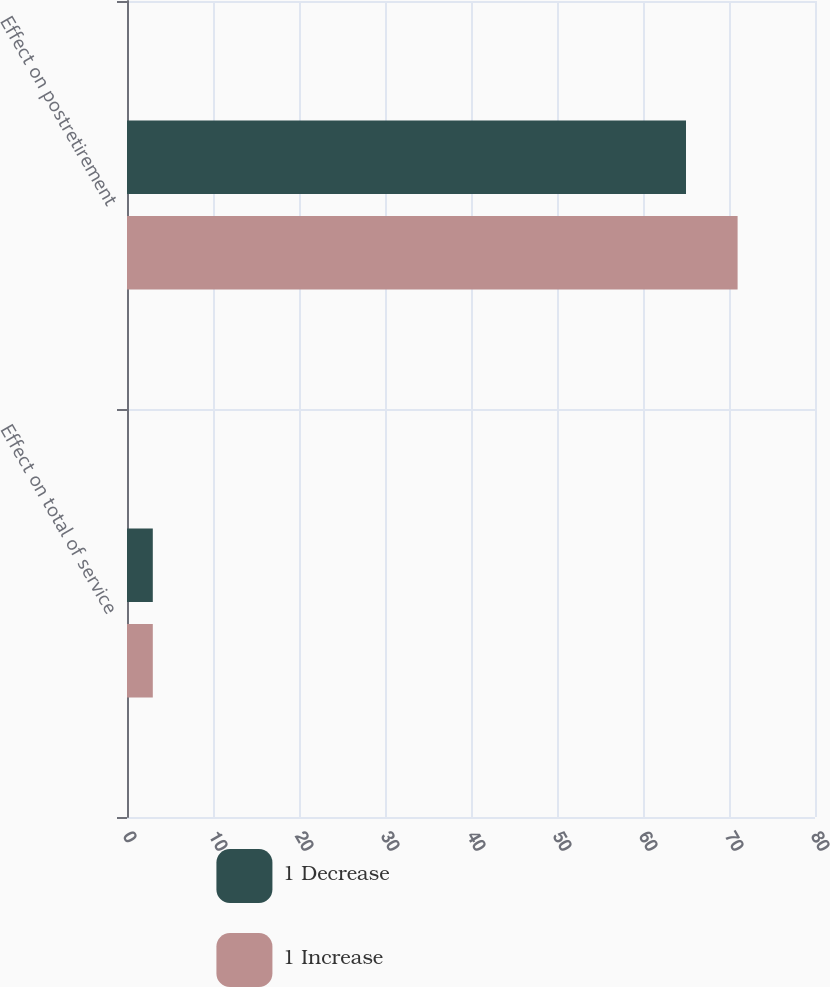Convert chart. <chart><loc_0><loc_0><loc_500><loc_500><stacked_bar_chart><ecel><fcel>Effect on total of service<fcel>Effect on postretirement<nl><fcel>1 Decrease<fcel>3<fcel>65<nl><fcel>1 Increase<fcel>3<fcel>71<nl></chart> 